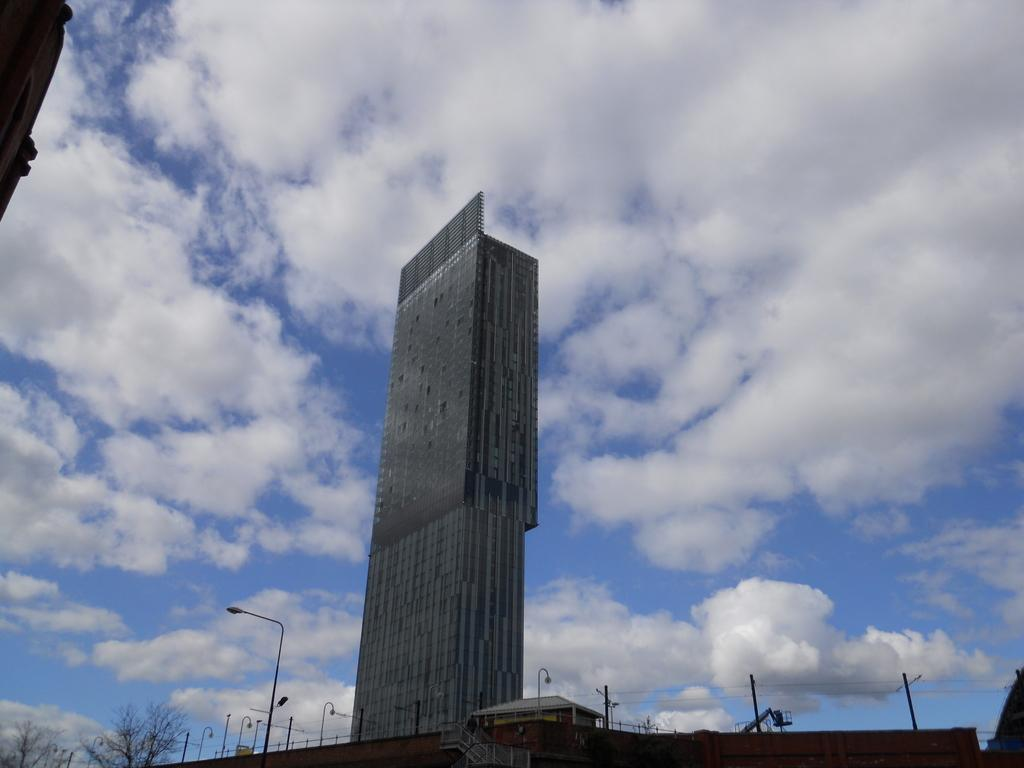What is the main structure in the center of the image? There is a building in the center of the image. What can be seen at the bottom of the image? There are poles, trees, and a shed at the bottom of the image. What is visible at the top of the image? The sky is visible at the top of the image. Can you see a yak grazing near the shed in the image? There is no yak present in the image. What type of wind is blowing in the image? The image does not depict any wind, so it is not possible to determine the type of wind blowing. 